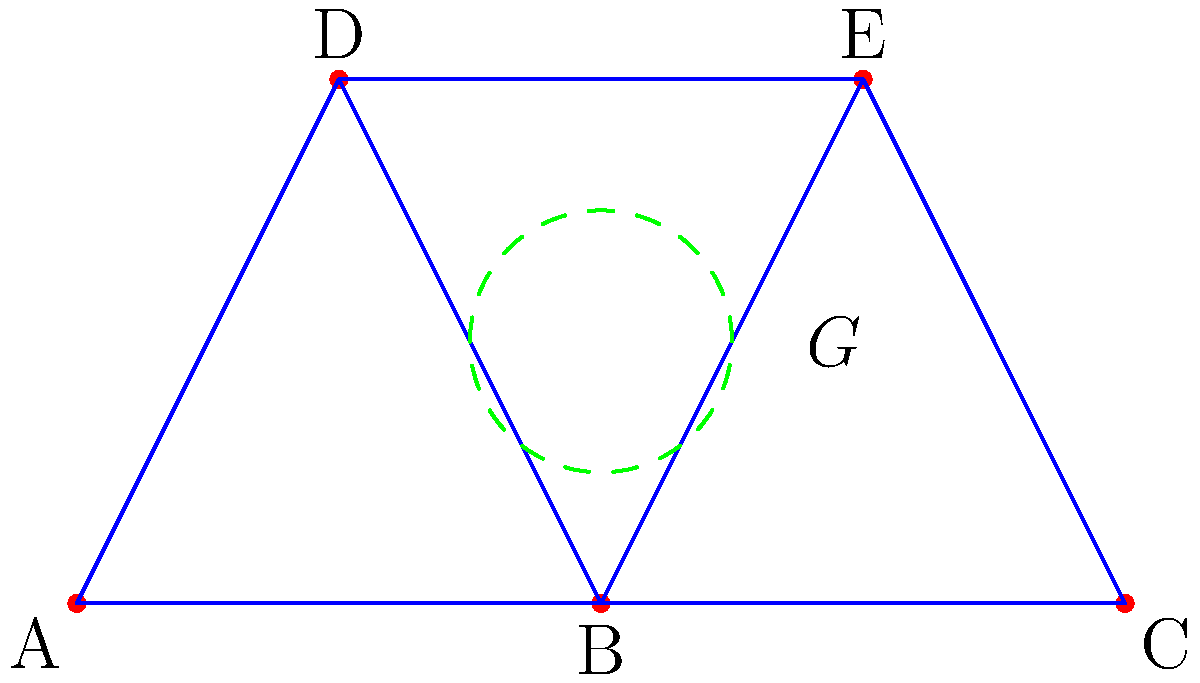In the truss design shown, a group theory visualization is applied to optimize the structure. If the symmetry group $G$ (represented by the dashed green circle) acts on the truss, which of the following statements is most likely to lead to an optimized design using abstract algebra principles? To answer this question, we need to consider how group theory can be applied to optimize truss designs:

1. Group theory in truss design focuses on symmetry and transformations that preserve the structure's integrity.

2. The symmetry group $G$ shown in the diagram suggests that there are rotational or reflectional symmetries in the truss design.

3. Optimizing the truss using group theory involves:
   a) Identifying symmetries in the structure
   b) Reducing the number of unique elements to analyze
   c) Simplifying calculations for stress and strain

4. In this case, we can observe that the truss has a vertical axis of symmetry through node B.

5. The group $G$ likely represents the cyclic group $C_2$ or the dihedral group $D_1$, which includes the identity transformation and a reflection about the vertical axis.

6. Applying group theory principles, we can:
   a) Analyze only half of the structure and apply the results to the other half
   b) Reduce the number of variables in optimization algorithms
   c) Ensure that any modifications preserve the symmetry, maintaining structural integrity

7. The most likely statement for optimization would involve leveraging this symmetry to simplify analysis and ensure balanced load distribution.

Therefore, the statement most likely to lead to an optimized design using abstract algebra principles would be one that focuses on utilizing the vertical symmetry to reduce computational complexity and ensure balanced load distribution across the truss.
Answer: Utilize vertical symmetry to reduce analysis complexity and ensure balanced load distribution. 